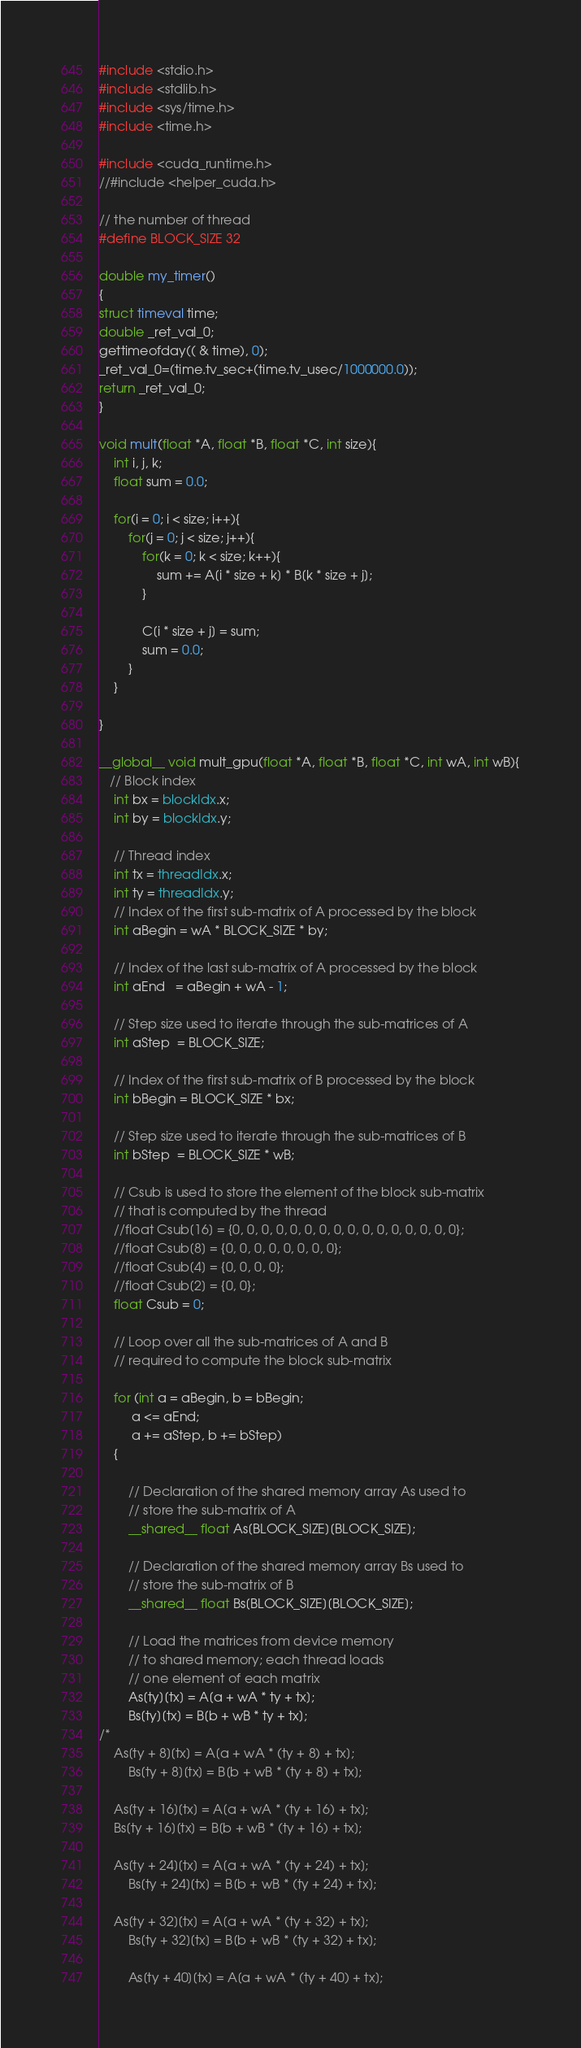<code> <loc_0><loc_0><loc_500><loc_500><_Cuda_>#include <stdio.h>
#include <stdlib.h>
#include <sys/time.h>
#include <time.h>

#include <cuda_runtime.h>
//#include <helper_cuda.h>

// the number of thread
#define BLOCK_SIZE 32

double my_timer()
{
struct timeval time;
double _ret_val_0;
gettimeofday(( & time), 0);
_ret_val_0=(time.tv_sec+(time.tv_usec/1000000.0));
return _ret_val_0;
}

void mult(float *A, float *B, float *C, int size){
  	int i, j, k;
  	float sum = 0.0;

	for(i = 0; i < size; i++){
		for(j = 0; j < size; j++){
			for(k = 0; k < size; k++){
				sum += A[i * size + k] * B[k * size + j];
			}
		
			C[i * size + j] = sum;
			sum = 0.0;
		}
	}

}

__global__ void mult_gpu(float *A, float *B, float *C, int wA, int wB){
   // Block index
    int bx = blockIdx.x;
    int by = blockIdx.y;

    // Thread index
    int tx = threadIdx.x;
    int ty = threadIdx.y;
    // Index of the first sub-matrix of A processed by the block
    int aBegin = wA * BLOCK_SIZE * by;

    // Index of the last sub-matrix of A processed by the block
    int aEnd   = aBegin + wA - 1;

    // Step size used to iterate through the sub-matrices of A
    int aStep  = BLOCK_SIZE;

    // Index of the first sub-matrix of B processed by the block
    int bBegin = BLOCK_SIZE * bx;

    // Step size used to iterate through the sub-matrices of B
    int bStep  = BLOCK_SIZE * wB;

    // Csub is used to store the element of the block sub-matrix
    // that is computed by the thread
    //float Csub[16] = {0, 0, 0, 0, 0, 0, 0, 0, 0, 0, 0, 0, 0, 0, 0, 0};
    //float Csub[8] = {0, 0, 0, 0, 0, 0, 0, 0};
    //float Csub[4] = {0, 0, 0, 0};
    //float Csub[2] = {0, 0};
    float Csub = 0;

    // Loop over all the sub-matrices of A and B
    // required to compute the block sub-matrix

    for (int a = aBegin, b = bBegin;
         a <= aEnd;
         a += aStep, b += bStep)
    {

        // Declaration of the shared memory array As used to
        // store the sub-matrix of A
        __shared__ float As[BLOCK_SIZE][BLOCK_SIZE];

        // Declaration of the shared memory array Bs used to
        // store the sub-matrix of B
        __shared__ float Bs[BLOCK_SIZE][BLOCK_SIZE];

        // Load the matrices from device memory
        // to shared memory; each thread loads
        // one element of each matrix
        As[ty][tx] = A[a + wA * ty + tx];
        Bs[ty][tx] = B[b + wB * ty + tx];
/*
	As[ty + 8][tx] = A[a + wA * (ty + 8) + tx];
        Bs[ty + 8][tx] = B[b + wB * (ty + 8) + tx];

	As[ty + 16][tx] = A[a + wA * (ty + 16) + tx];
	Bs[ty + 16][tx] = B[b + wB * (ty + 16) + tx];

	As[ty + 24][tx] = A[a + wA * (ty + 24) + tx];
        Bs[ty + 24][tx] = B[b + wB * (ty + 24) + tx];

	As[ty + 32][tx] = A[a + wA * (ty + 32) + tx];
        Bs[ty + 32][tx] = B[b + wB * (ty + 32) + tx];

        As[ty + 40][tx] = A[a + wA * (ty + 40) + tx];</code> 